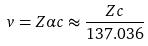Convert formula to latex. <formula><loc_0><loc_0><loc_500><loc_500>v = Z \alpha c \approx \frac { Z c } { 1 3 7 . 0 3 6 }</formula> 